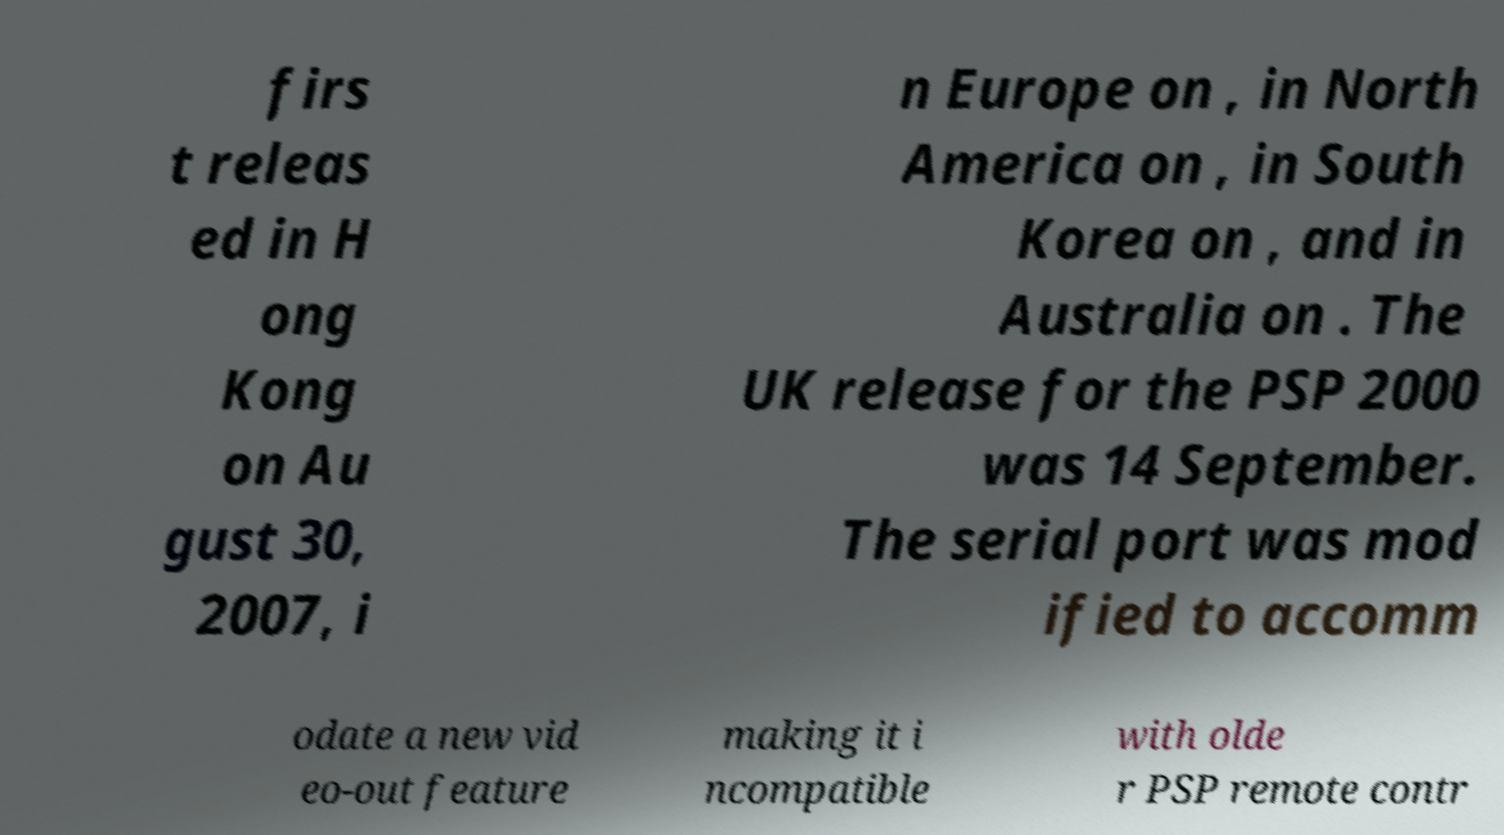Could you extract and type out the text from this image? firs t releas ed in H ong Kong on Au gust 30, 2007, i n Europe on , in North America on , in South Korea on , and in Australia on . The UK release for the PSP 2000 was 14 September. The serial port was mod ified to accomm odate a new vid eo-out feature making it i ncompatible with olde r PSP remote contr 